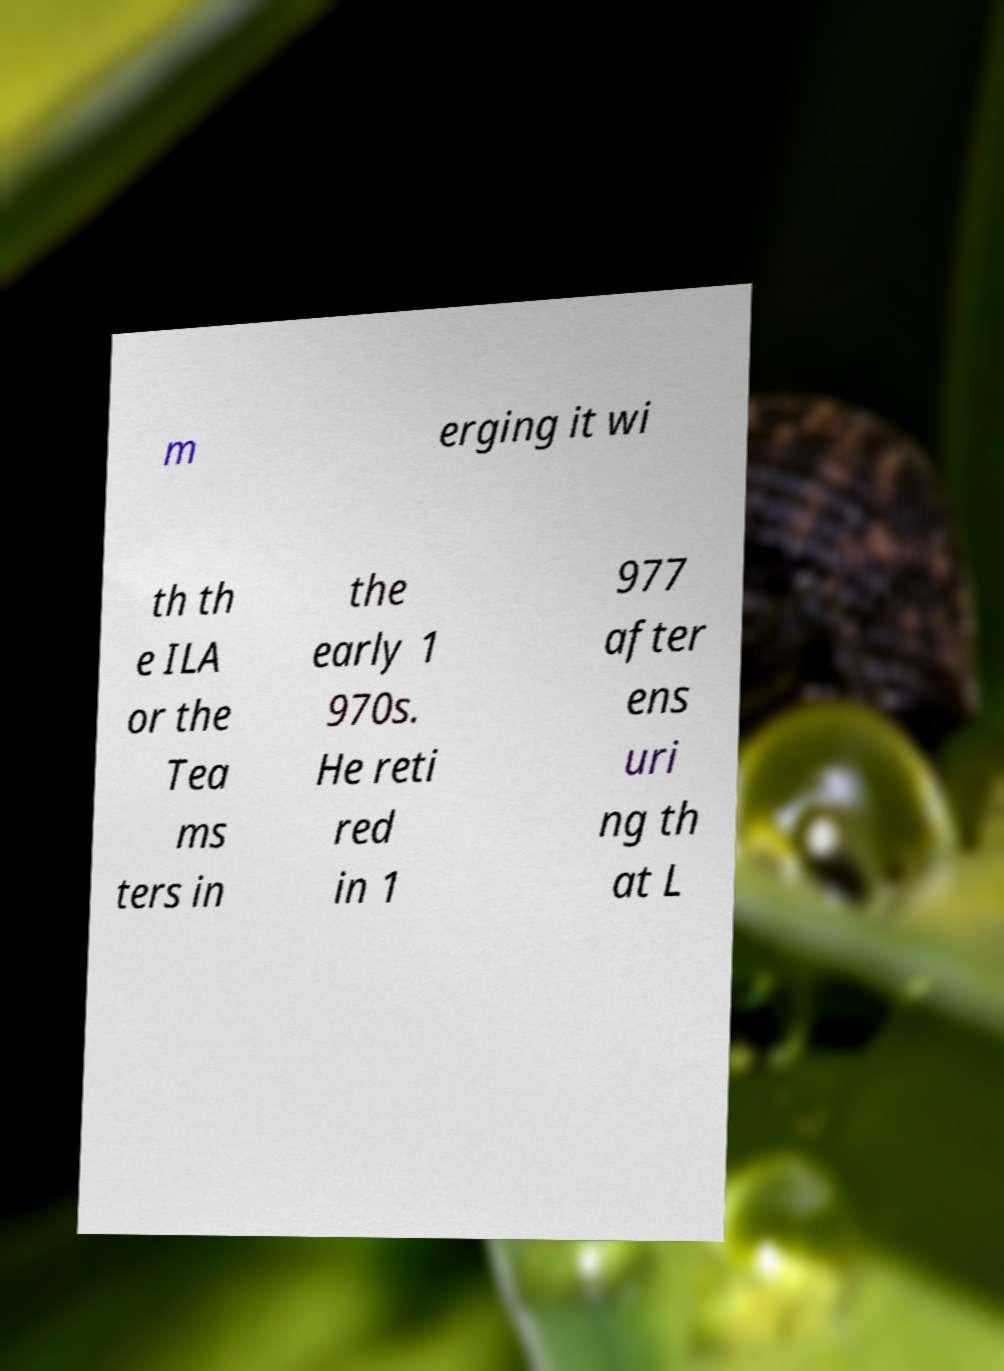Please read and relay the text visible in this image. What does it say? m erging it wi th th e ILA or the Tea ms ters in the early 1 970s. He reti red in 1 977 after ens uri ng th at L 